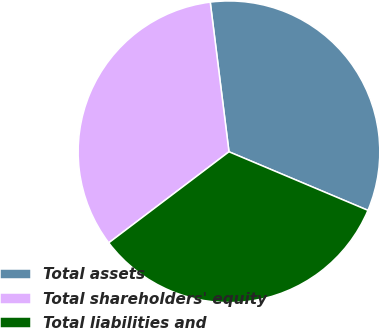<chart> <loc_0><loc_0><loc_500><loc_500><pie_chart><fcel>Total assets<fcel>Total shareholders' equity<fcel>Total liabilities and<nl><fcel>33.33%<fcel>33.33%<fcel>33.33%<nl></chart> 